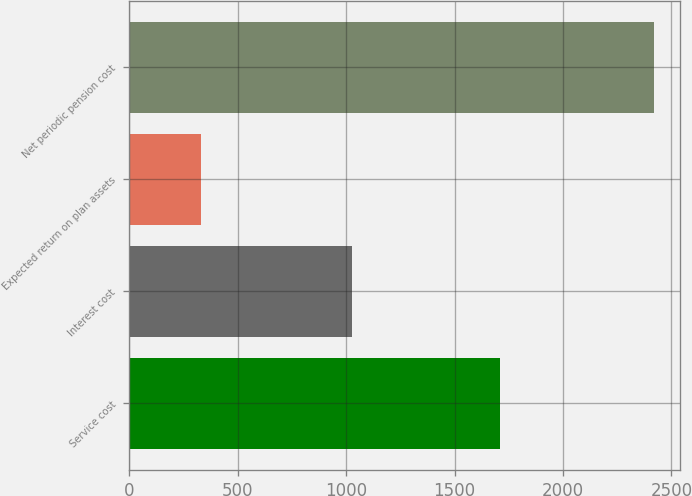Convert chart to OTSL. <chart><loc_0><loc_0><loc_500><loc_500><bar_chart><fcel>Service cost<fcel>Interest cost<fcel>Expected return on plan assets<fcel>Net periodic pension cost<nl><fcel>1710<fcel>1027<fcel>329<fcel>2419<nl></chart> 